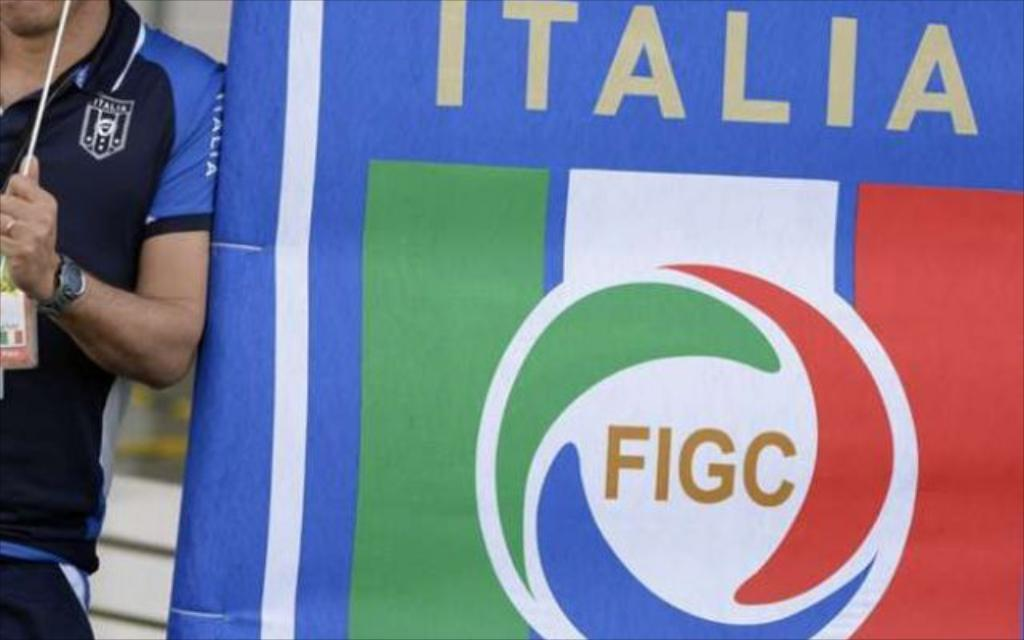Who or what is the main subject in the image? There is a person in the image. What is the person standing beside in the image? The person is standing beside a football banner. What is the person holding in his hand? The person is holding a stick in his hand. Can you describe any accessories the person is wearing? The person is wearing a watch on his hand and an ID card. What type of steel is visible in the image? There is no steel present in the image. What ingredients are used to make the stew in the image? There is no stew present in the image. 